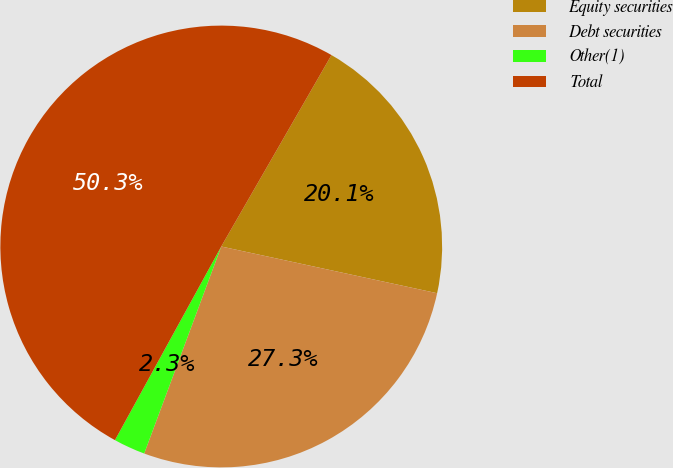<chart> <loc_0><loc_0><loc_500><loc_500><pie_chart><fcel>Equity securities<fcel>Debt securities<fcel>Other(1)<fcel>Total<nl><fcel>20.08%<fcel>27.28%<fcel>2.32%<fcel>50.33%<nl></chart> 